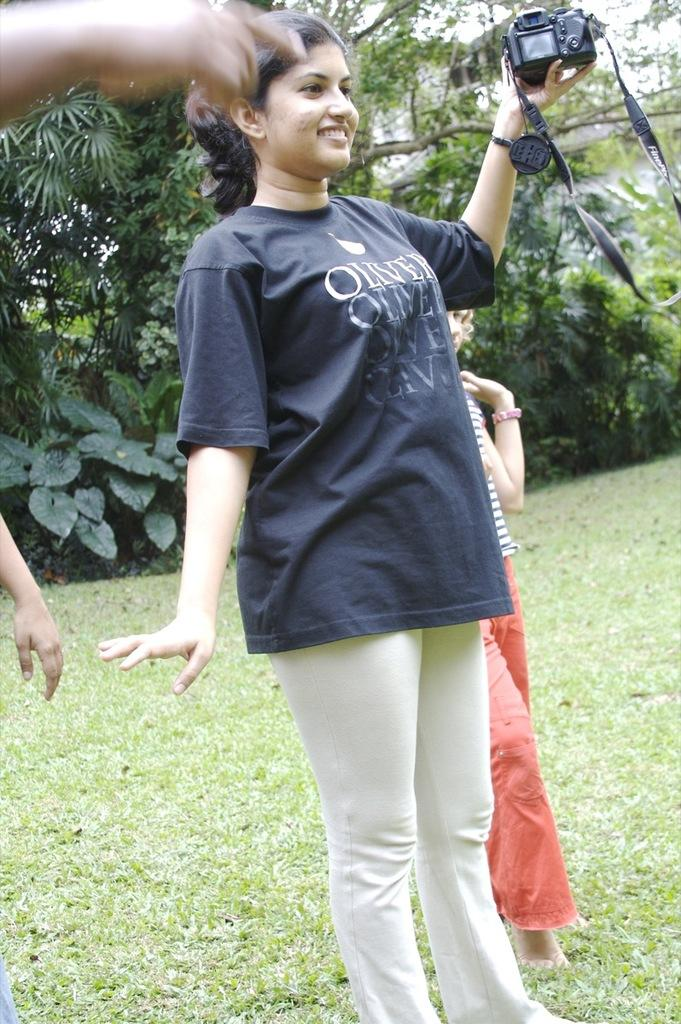Who is the main subject in the image? There is a woman in the image. What is the woman doing in the image? The woman is standing and smiling. What is the woman holding in her hands? The woman is holding a camera in her hands. Can you describe the background of the image? There is a person standing on the grass in the background, and trees are visible in the background. What type of vase can be seen in the image? There is no vase present in the image. 